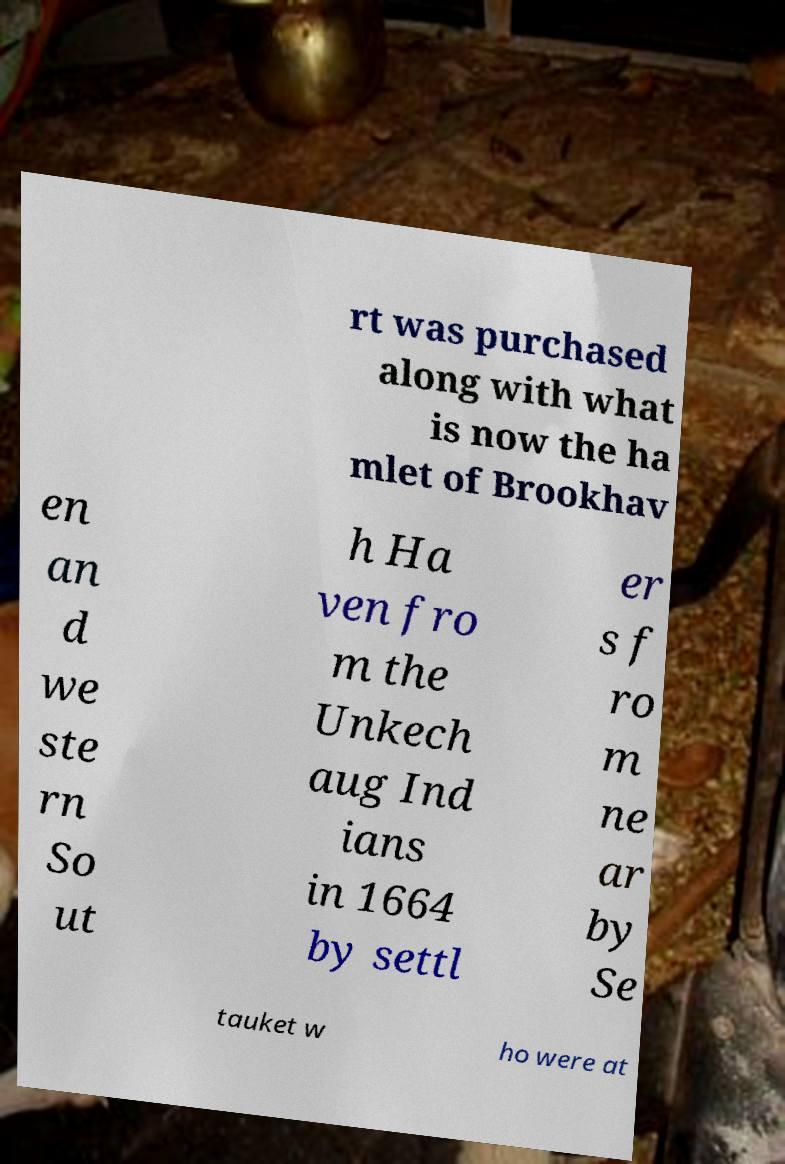Could you extract and type out the text from this image? rt was purchased along with what is now the ha mlet of Brookhav en an d we ste rn So ut h Ha ven fro m the Unkech aug Ind ians in 1664 by settl er s f ro m ne ar by Se tauket w ho were at 